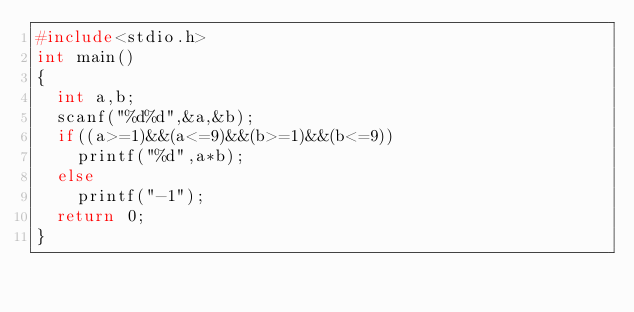Convert code to text. <code><loc_0><loc_0><loc_500><loc_500><_C_>#include<stdio.h>
int main()
{
  int a,b;
  scanf("%d%d",&a,&b);
  if((a>=1)&&(a<=9)&&(b>=1)&&(b<=9))
    printf("%d",a*b);
  else
    printf("-1");
  return 0;
}</code> 